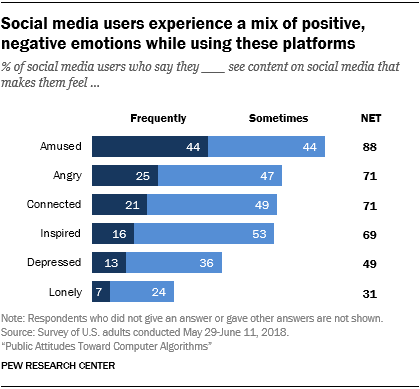Mention a couple of crucial points in this snapshot. Social media usage is associated with a decrease in feelings of loneliness, as reported by individuals. According to a recent survey, only 0.69% of people feel inspired by using social media. 